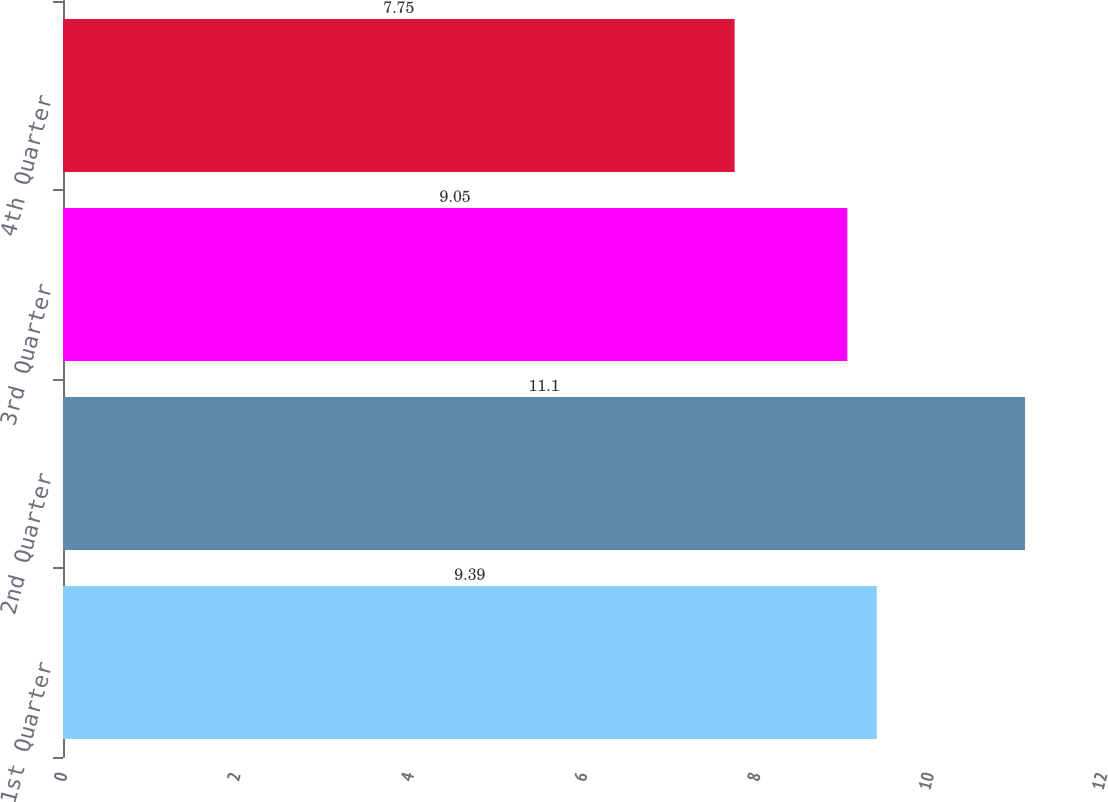<chart> <loc_0><loc_0><loc_500><loc_500><bar_chart><fcel>1st Quarter<fcel>2nd Quarter<fcel>3rd Quarter<fcel>4th Quarter<nl><fcel>9.39<fcel>11.1<fcel>9.05<fcel>7.75<nl></chart> 